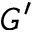<formula> <loc_0><loc_0><loc_500><loc_500>G ^ { \prime }</formula> 